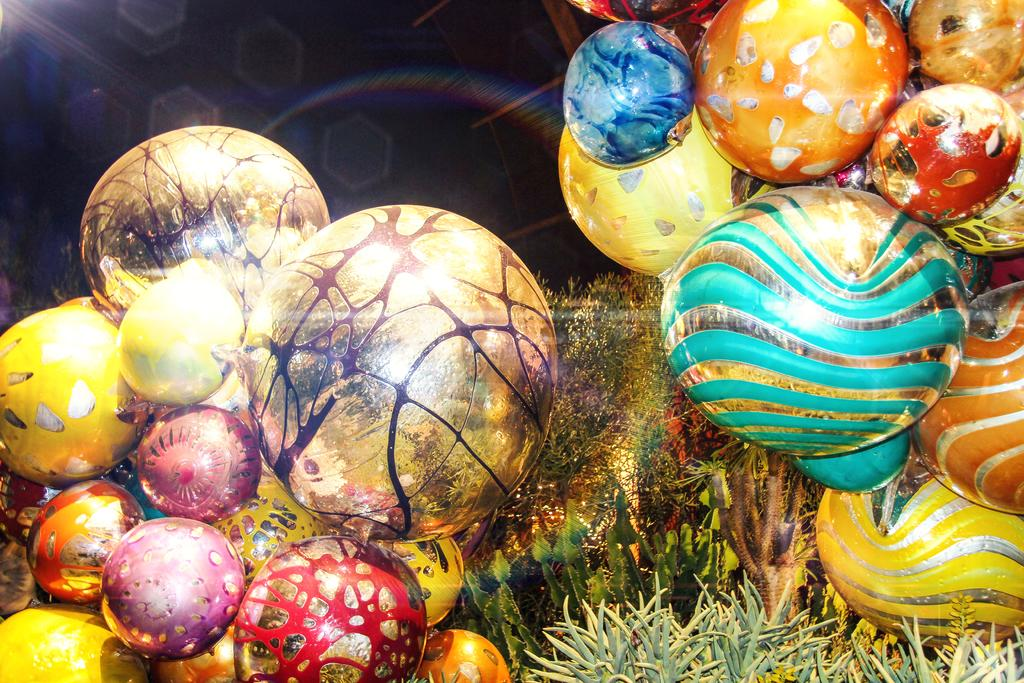What type of decorative items can be seen in the image? There are circular shape decorative items in the image. What other objects are present in the foreground of the image? House plants are present in the foreground of the image. What is the focus of the background in the image? There is a light focus in the background of the image. How would you describe the overall lighting in the background of the image? The background view is dark. What type of ship can be seen sailing in the background of the image? There is no ship present in the image; the background view is dark and focused on a light source. How many knots are tied on the tree in the image? There is no tree present in the image, only house plants and circular decorative items. 